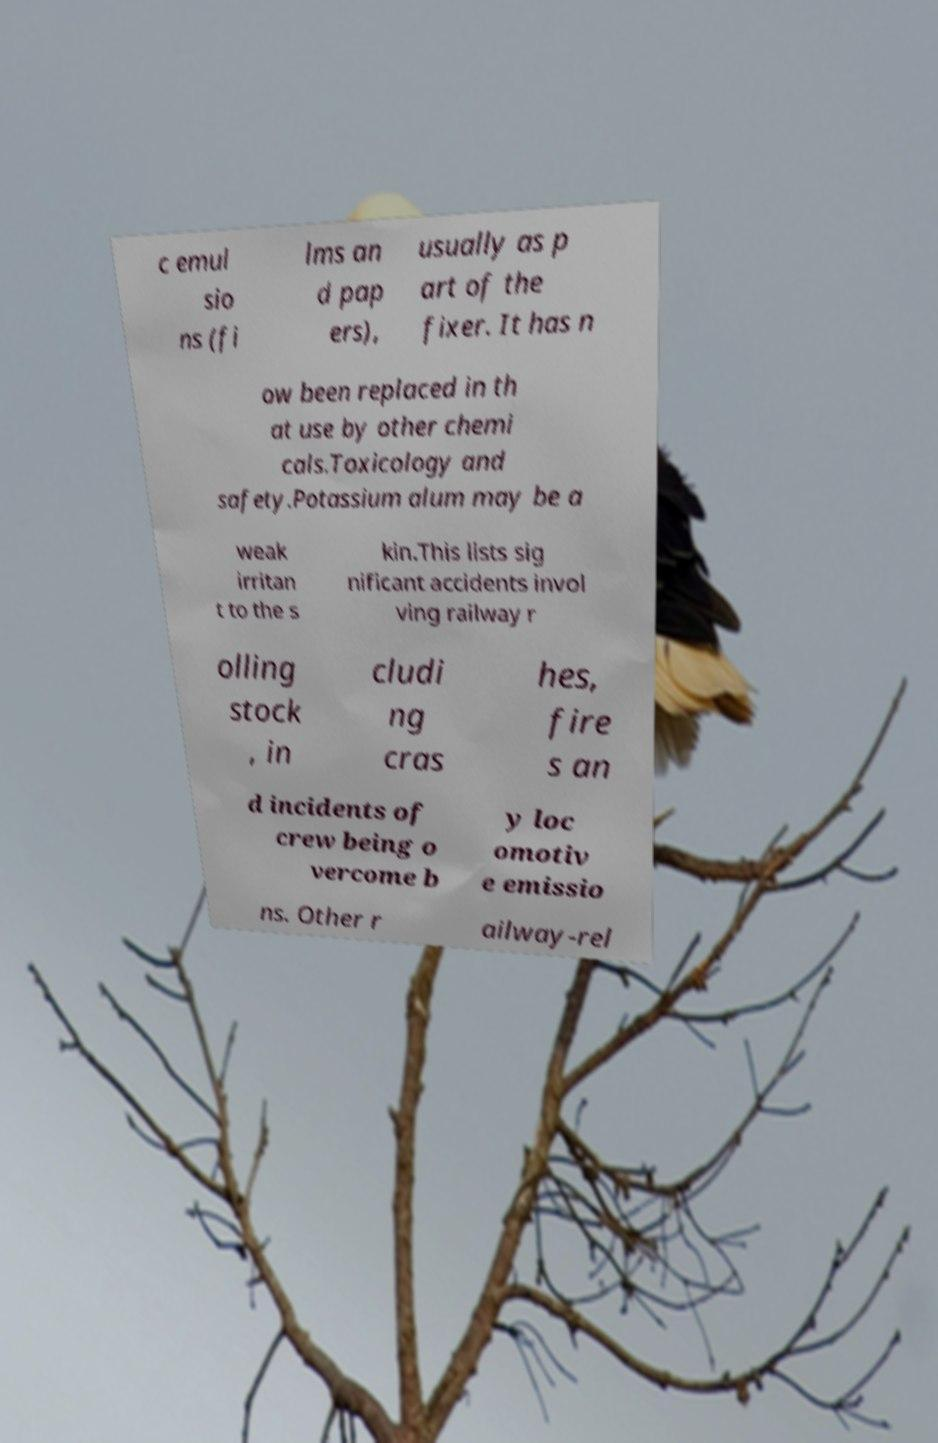Please identify and transcribe the text found in this image. c emul sio ns (fi lms an d pap ers), usually as p art of the fixer. It has n ow been replaced in th at use by other chemi cals.Toxicology and safety.Potassium alum may be a weak irritan t to the s kin.This lists sig nificant accidents invol ving railway r olling stock , in cludi ng cras hes, fire s an d incidents of crew being o vercome b y loc omotiv e emissio ns. Other r ailway-rel 